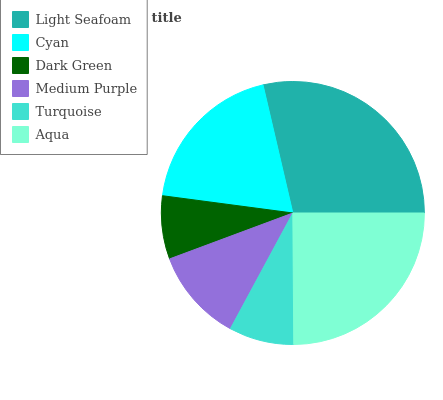Is Dark Green the minimum?
Answer yes or no. Yes. Is Light Seafoam the maximum?
Answer yes or no. Yes. Is Cyan the minimum?
Answer yes or no. No. Is Cyan the maximum?
Answer yes or no. No. Is Light Seafoam greater than Cyan?
Answer yes or no. Yes. Is Cyan less than Light Seafoam?
Answer yes or no. Yes. Is Cyan greater than Light Seafoam?
Answer yes or no. No. Is Light Seafoam less than Cyan?
Answer yes or no. No. Is Cyan the high median?
Answer yes or no. Yes. Is Medium Purple the low median?
Answer yes or no. Yes. Is Turquoise the high median?
Answer yes or no. No. Is Cyan the low median?
Answer yes or no. No. 